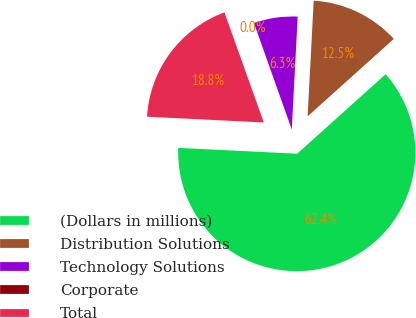<chart> <loc_0><loc_0><loc_500><loc_500><pie_chart><fcel>(Dollars in millions)<fcel>Distribution Solutions<fcel>Technology Solutions<fcel>Corporate<fcel>Total<nl><fcel>62.43%<fcel>12.51%<fcel>6.27%<fcel>0.03%<fcel>18.75%<nl></chart> 